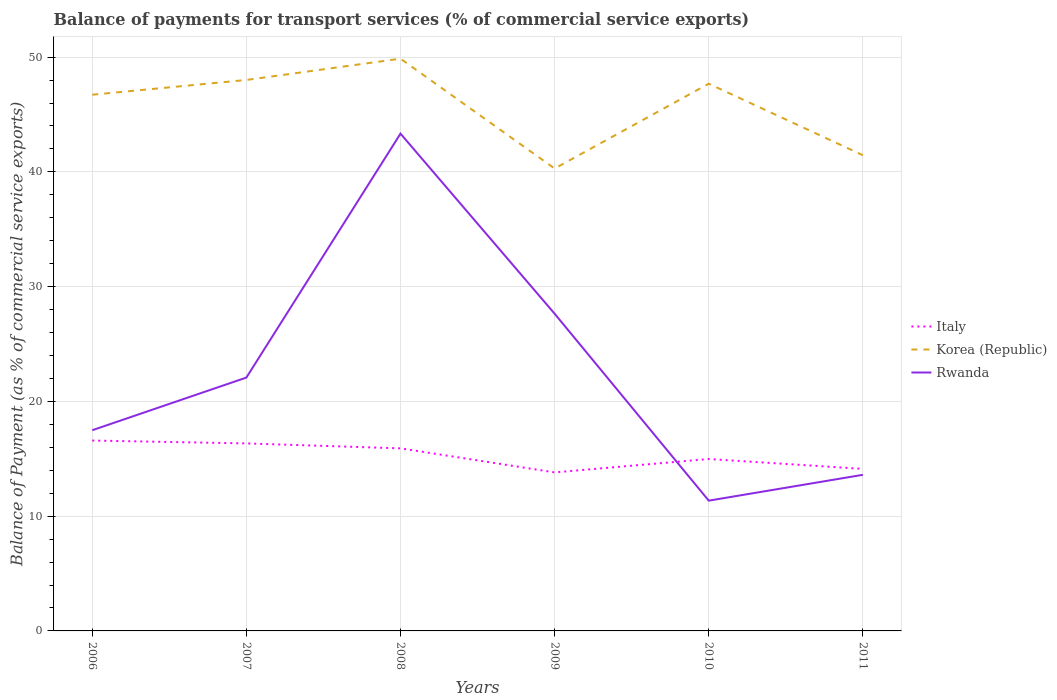Is the number of lines equal to the number of legend labels?
Your answer should be very brief. Yes. Across all years, what is the maximum balance of payments for transport services in Rwanda?
Make the answer very short. 11.35. What is the total balance of payments for transport services in Korea (Republic) in the graph?
Keep it short and to the point. -7.39. What is the difference between the highest and the second highest balance of payments for transport services in Italy?
Your response must be concise. 2.77. Is the balance of payments for transport services in Italy strictly greater than the balance of payments for transport services in Korea (Republic) over the years?
Provide a short and direct response. Yes. What is the difference between two consecutive major ticks on the Y-axis?
Ensure brevity in your answer.  10. Are the values on the major ticks of Y-axis written in scientific E-notation?
Ensure brevity in your answer.  No. Does the graph contain any zero values?
Offer a terse response. No. Does the graph contain grids?
Keep it short and to the point. Yes. Where does the legend appear in the graph?
Keep it short and to the point. Center right. What is the title of the graph?
Your answer should be compact. Balance of payments for transport services (% of commercial service exports). What is the label or title of the X-axis?
Ensure brevity in your answer.  Years. What is the label or title of the Y-axis?
Offer a terse response. Balance of Payment (as % of commercial service exports). What is the Balance of Payment (as % of commercial service exports) in Italy in 2006?
Keep it short and to the point. 16.59. What is the Balance of Payment (as % of commercial service exports) in Korea (Republic) in 2006?
Ensure brevity in your answer.  46.72. What is the Balance of Payment (as % of commercial service exports) in Rwanda in 2006?
Offer a very short reply. 17.49. What is the Balance of Payment (as % of commercial service exports) of Italy in 2007?
Your response must be concise. 16.34. What is the Balance of Payment (as % of commercial service exports) in Korea (Republic) in 2007?
Offer a very short reply. 48.01. What is the Balance of Payment (as % of commercial service exports) of Rwanda in 2007?
Your answer should be very brief. 22.08. What is the Balance of Payment (as % of commercial service exports) of Italy in 2008?
Offer a very short reply. 15.91. What is the Balance of Payment (as % of commercial service exports) of Korea (Republic) in 2008?
Keep it short and to the point. 49.86. What is the Balance of Payment (as % of commercial service exports) in Rwanda in 2008?
Offer a very short reply. 43.33. What is the Balance of Payment (as % of commercial service exports) in Italy in 2009?
Provide a succinct answer. 13.81. What is the Balance of Payment (as % of commercial service exports) in Korea (Republic) in 2009?
Ensure brevity in your answer.  40.29. What is the Balance of Payment (as % of commercial service exports) in Rwanda in 2009?
Your answer should be very brief. 27.64. What is the Balance of Payment (as % of commercial service exports) in Italy in 2010?
Ensure brevity in your answer.  14.98. What is the Balance of Payment (as % of commercial service exports) of Korea (Republic) in 2010?
Keep it short and to the point. 47.68. What is the Balance of Payment (as % of commercial service exports) in Rwanda in 2010?
Make the answer very short. 11.35. What is the Balance of Payment (as % of commercial service exports) in Italy in 2011?
Give a very brief answer. 14.12. What is the Balance of Payment (as % of commercial service exports) in Korea (Republic) in 2011?
Give a very brief answer. 41.45. What is the Balance of Payment (as % of commercial service exports) in Rwanda in 2011?
Your response must be concise. 13.6. Across all years, what is the maximum Balance of Payment (as % of commercial service exports) of Italy?
Give a very brief answer. 16.59. Across all years, what is the maximum Balance of Payment (as % of commercial service exports) of Korea (Republic)?
Your answer should be very brief. 49.86. Across all years, what is the maximum Balance of Payment (as % of commercial service exports) of Rwanda?
Your answer should be compact. 43.33. Across all years, what is the minimum Balance of Payment (as % of commercial service exports) in Italy?
Your response must be concise. 13.81. Across all years, what is the minimum Balance of Payment (as % of commercial service exports) of Korea (Republic)?
Offer a very short reply. 40.29. Across all years, what is the minimum Balance of Payment (as % of commercial service exports) of Rwanda?
Keep it short and to the point. 11.35. What is the total Balance of Payment (as % of commercial service exports) of Italy in the graph?
Make the answer very short. 91.75. What is the total Balance of Payment (as % of commercial service exports) in Korea (Republic) in the graph?
Offer a terse response. 274.02. What is the total Balance of Payment (as % of commercial service exports) in Rwanda in the graph?
Offer a terse response. 135.5. What is the difference between the Balance of Payment (as % of commercial service exports) in Italy in 2006 and that in 2007?
Your answer should be very brief. 0.25. What is the difference between the Balance of Payment (as % of commercial service exports) in Korea (Republic) in 2006 and that in 2007?
Keep it short and to the point. -1.29. What is the difference between the Balance of Payment (as % of commercial service exports) of Rwanda in 2006 and that in 2007?
Give a very brief answer. -4.59. What is the difference between the Balance of Payment (as % of commercial service exports) in Italy in 2006 and that in 2008?
Provide a succinct answer. 0.68. What is the difference between the Balance of Payment (as % of commercial service exports) of Korea (Republic) in 2006 and that in 2008?
Give a very brief answer. -3.14. What is the difference between the Balance of Payment (as % of commercial service exports) in Rwanda in 2006 and that in 2008?
Your response must be concise. -25.84. What is the difference between the Balance of Payment (as % of commercial service exports) of Italy in 2006 and that in 2009?
Provide a succinct answer. 2.77. What is the difference between the Balance of Payment (as % of commercial service exports) of Korea (Republic) in 2006 and that in 2009?
Your response must be concise. 6.43. What is the difference between the Balance of Payment (as % of commercial service exports) in Rwanda in 2006 and that in 2009?
Give a very brief answer. -10.15. What is the difference between the Balance of Payment (as % of commercial service exports) in Italy in 2006 and that in 2010?
Your response must be concise. 1.61. What is the difference between the Balance of Payment (as % of commercial service exports) of Korea (Republic) in 2006 and that in 2010?
Keep it short and to the point. -0.96. What is the difference between the Balance of Payment (as % of commercial service exports) in Rwanda in 2006 and that in 2010?
Your response must be concise. 6.14. What is the difference between the Balance of Payment (as % of commercial service exports) in Italy in 2006 and that in 2011?
Provide a short and direct response. 2.47. What is the difference between the Balance of Payment (as % of commercial service exports) in Korea (Republic) in 2006 and that in 2011?
Provide a succinct answer. 5.27. What is the difference between the Balance of Payment (as % of commercial service exports) of Rwanda in 2006 and that in 2011?
Provide a succinct answer. 3.89. What is the difference between the Balance of Payment (as % of commercial service exports) of Italy in 2007 and that in 2008?
Ensure brevity in your answer.  0.43. What is the difference between the Balance of Payment (as % of commercial service exports) of Korea (Republic) in 2007 and that in 2008?
Your response must be concise. -1.86. What is the difference between the Balance of Payment (as % of commercial service exports) in Rwanda in 2007 and that in 2008?
Offer a very short reply. -21.26. What is the difference between the Balance of Payment (as % of commercial service exports) of Italy in 2007 and that in 2009?
Your response must be concise. 2.53. What is the difference between the Balance of Payment (as % of commercial service exports) in Korea (Republic) in 2007 and that in 2009?
Ensure brevity in your answer.  7.72. What is the difference between the Balance of Payment (as % of commercial service exports) of Rwanda in 2007 and that in 2009?
Provide a short and direct response. -5.57. What is the difference between the Balance of Payment (as % of commercial service exports) in Italy in 2007 and that in 2010?
Make the answer very short. 1.36. What is the difference between the Balance of Payment (as % of commercial service exports) in Korea (Republic) in 2007 and that in 2010?
Your response must be concise. 0.33. What is the difference between the Balance of Payment (as % of commercial service exports) in Rwanda in 2007 and that in 2010?
Provide a succinct answer. 10.72. What is the difference between the Balance of Payment (as % of commercial service exports) in Italy in 2007 and that in 2011?
Your answer should be very brief. 2.22. What is the difference between the Balance of Payment (as % of commercial service exports) in Korea (Republic) in 2007 and that in 2011?
Make the answer very short. 6.56. What is the difference between the Balance of Payment (as % of commercial service exports) of Rwanda in 2007 and that in 2011?
Give a very brief answer. 8.47. What is the difference between the Balance of Payment (as % of commercial service exports) of Italy in 2008 and that in 2009?
Ensure brevity in your answer.  2.09. What is the difference between the Balance of Payment (as % of commercial service exports) of Korea (Republic) in 2008 and that in 2009?
Provide a succinct answer. 9.57. What is the difference between the Balance of Payment (as % of commercial service exports) of Rwanda in 2008 and that in 2009?
Your answer should be very brief. 15.69. What is the difference between the Balance of Payment (as % of commercial service exports) in Italy in 2008 and that in 2010?
Give a very brief answer. 0.93. What is the difference between the Balance of Payment (as % of commercial service exports) of Korea (Republic) in 2008 and that in 2010?
Keep it short and to the point. 2.18. What is the difference between the Balance of Payment (as % of commercial service exports) in Rwanda in 2008 and that in 2010?
Ensure brevity in your answer.  31.98. What is the difference between the Balance of Payment (as % of commercial service exports) of Italy in 2008 and that in 2011?
Ensure brevity in your answer.  1.79. What is the difference between the Balance of Payment (as % of commercial service exports) of Korea (Republic) in 2008 and that in 2011?
Provide a succinct answer. 8.41. What is the difference between the Balance of Payment (as % of commercial service exports) of Rwanda in 2008 and that in 2011?
Offer a terse response. 29.73. What is the difference between the Balance of Payment (as % of commercial service exports) in Italy in 2009 and that in 2010?
Make the answer very short. -1.17. What is the difference between the Balance of Payment (as % of commercial service exports) of Korea (Republic) in 2009 and that in 2010?
Your response must be concise. -7.39. What is the difference between the Balance of Payment (as % of commercial service exports) of Rwanda in 2009 and that in 2010?
Offer a very short reply. 16.29. What is the difference between the Balance of Payment (as % of commercial service exports) of Italy in 2009 and that in 2011?
Give a very brief answer. -0.3. What is the difference between the Balance of Payment (as % of commercial service exports) in Korea (Republic) in 2009 and that in 2011?
Make the answer very short. -1.16. What is the difference between the Balance of Payment (as % of commercial service exports) of Rwanda in 2009 and that in 2011?
Offer a very short reply. 14.04. What is the difference between the Balance of Payment (as % of commercial service exports) in Italy in 2010 and that in 2011?
Your answer should be very brief. 0.86. What is the difference between the Balance of Payment (as % of commercial service exports) in Korea (Republic) in 2010 and that in 2011?
Keep it short and to the point. 6.23. What is the difference between the Balance of Payment (as % of commercial service exports) in Rwanda in 2010 and that in 2011?
Ensure brevity in your answer.  -2.25. What is the difference between the Balance of Payment (as % of commercial service exports) of Italy in 2006 and the Balance of Payment (as % of commercial service exports) of Korea (Republic) in 2007?
Ensure brevity in your answer.  -31.42. What is the difference between the Balance of Payment (as % of commercial service exports) of Italy in 2006 and the Balance of Payment (as % of commercial service exports) of Rwanda in 2007?
Your answer should be very brief. -5.49. What is the difference between the Balance of Payment (as % of commercial service exports) in Korea (Republic) in 2006 and the Balance of Payment (as % of commercial service exports) in Rwanda in 2007?
Offer a very short reply. 24.65. What is the difference between the Balance of Payment (as % of commercial service exports) of Italy in 2006 and the Balance of Payment (as % of commercial service exports) of Korea (Republic) in 2008?
Offer a terse response. -33.28. What is the difference between the Balance of Payment (as % of commercial service exports) of Italy in 2006 and the Balance of Payment (as % of commercial service exports) of Rwanda in 2008?
Your answer should be very brief. -26.74. What is the difference between the Balance of Payment (as % of commercial service exports) of Korea (Republic) in 2006 and the Balance of Payment (as % of commercial service exports) of Rwanda in 2008?
Give a very brief answer. 3.39. What is the difference between the Balance of Payment (as % of commercial service exports) in Italy in 2006 and the Balance of Payment (as % of commercial service exports) in Korea (Republic) in 2009?
Give a very brief answer. -23.7. What is the difference between the Balance of Payment (as % of commercial service exports) in Italy in 2006 and the Balance of Payment (as % of commercial service exports) in Rwanda in 2009?
Give a very brief answer. -11.05. What is the difference between the Balance of Payment (as % of commercial service exports) in Korea (Republic) in 2006 and the Balance of Payment (as % of commercial service exports) in Rwanda in 2009?
Offer a terse response. 19.08. What is the difference between the Balance of Payment (as % of commercial service exports) in Italy in 2006 and the Balance of Payment (as % of commercial service exports) in Korea (Republic) in 2010?
Make the answer very short. -31.09. What is the difference between the Balance of Payment (as % of commercial service exports) of Italy in 2006 and the Balance of Payment (as % of commercial service exports) of Rwanda in 2010?
Provide a short and direct response. 5.24. What is the difference between the Balance of Payment (as % of commercial service exports) of Korea (Republic) in 2006 and the Balance of Payment (as % of commercial service exports) of Rwanda in 2010?
Your answer should be compact. 35.37. What is the difference between the Balance of Payment (as % of commercial service exports) of Italy in 2006 and the Balance of Payment (as % of commercial service exports) of Korea (Republic) in 2011?
Ensure brevity in your answer.  -24.86. What is the difference between the Balance of Payment (as % of commercial service exports) in Italy in 2006 and the Balance of Payment (as % of commercial service exports) in Rwanda in 2011?
Offer a terse response. 2.99. What is the difference between the Balance of Payment (as % of commercial service exports) in Korea (Republic) in 2006 and the Balance of Payment (as % of commercial service exports) in Rwanda in 2011?
Provide a succinct answer. 33.12. What is the difference between the Balance of Payment (as % of commercial service exports) of Italy in 2007 and the Balance of Payment (as % of commercial service exports) of Korea (Republic) in 2008?
Provide a succinct answer. -33.53. What is the difference between the Balance of Payment (as % of commercial service exports) of Italy in 2007 and the Balance of Payment (as % of commercial service exports) of Rwanda in 2008?
Provide a succinct answer. -26.99. What is the difference between the Balance of Payment (as % of commercial service exports) of Korea (Republic) in 2007 and the Balance of Payment (as % of commercial service exports) of Rwanda in 2008?
Provide a short and direct response. 4.68. What is the difference between the Balance of Payment (as % of commercial service exports) in Italy in 2007 and the Balance of Payment (as % of commercial service exports) in Korea (Republic) in 2009?
Ensure brevity in your answer.  -23.95. What is the difference between the Balance of Payment (as % of commercial service exports) in Italy in 2007 and the Balance of Payment (as % of commercial service exports) in Rwanda in 2009?
Your answer should be very brief. -11.3. What is the difference between the Balance of Payment (as % of commercial service exports) of Korea (Republic) in 2007 and the Balance of Payment (as % of commercial service exports) of Rwanda in 2009?
Your answer should be very brief. 20.37. What is the difference between the Balance of Payment (as % of commercial service exports) in Italy in 2007 and the Balance of Payment (as % of commercial service exports) in Korea (Republic) in 2010?
Make the answer very short. -31.34. What is the difference between the Balance of Payment (as % of commercial service exports) of Italy in 2007 and the Balance of Payment (as % of commercial service exports) of Rwanda in 2010?
Offer a very short reply. 4.99. What is the difference between the Balance of Payment (as % of commercial service exports) in Korea (Republic) in 2007 and the Balance of Payment (as % of commercial service exports) in Rwanda in 2010?
Your answer should be compact. 36.66. What is the difference between the Balance of Payment (as % of commercial service exports) of Italy in 2007 and the Balance of Payment (as % of commercial service exports) of Korea (Republic) in 2011?
Provide a short and direct response. -25.11. What is the difference between the Balance of Payment (as % of commercial service exports) in Italy in 2007 and the Balance of Payment (as % of commercial service exports) in Rwanda in 2011?
Offer a very short reply. 2.74. What is the difference between the Balance of Payment (as % of commercial service exports) of Korea (Republic) in 2007 and the Balance of Payment (as % of commercial service exports) of Rwanda in 2011?
Your response must be concise. 34.41. What is the difference between the Balance of Payment (as % of commercial service exports) in Italy in 2008 and the Balance of Payment (as % of commercial service exports) in Korea (Republic) in 2009?
Offer a terse response. -24.38. What is the difference between the Balance of Payment (as % of commercial service exports) in Italy in 2008 and the Balance of Payment (as % of commercial service exports) in Rwanda in 2009?
Give a very brief answer. -11.73. What is the difference between the Balance of Payment (as % of commercial service exports) of Korea (Republic) in 2008 and the Balance of Payment (as % of commercial service exports) of Rwanda in 2009?
Give a very brief answer. 22.22. What is the difference between the Balance of Payment (as % of commercial service exports) in Italy in 2008 and the Balance of Payment (as % of commercial service exports) in Korea (Republic) in 2010?
Offer a terse response. -31.77. What is the difference between the Balance of Payment (as % of commercial service exports) of Italy in 2008 and the Balance of Payment (as % of commercial service exports) of Rwanda in 2010?
Provide a short and direct response. 4.56. What is the difference between the Balance of Payment (as % of commercial service exports) in Korea (Republic) in 2008 and the Balance of Payment (as % of commercial service exports) in Rwanda in 2010?
Make the answer very short. 38.51. What is the difference between the Balance of Payment (as % of commercial service exports) of Italy in 2008 and the Balance of Payment (as % of commercial service exports) of Korea (Republic) in 2011?
Provide a short and direct response. -25.54. What is the difference between the Balance of Payment (as % of commercial service exports) in Italy in 2008 and the Balance of Payment (as % of commercial service exports) in Rwanda in 2011?
Your response must be concise. 2.31. What is the difference between the Balance of Payment (as % of commercial service exports) in Korea (Republic) in 2008 and the Balance of Payment (as % of commercial service exports) in Rwanda in 2011?
Keep it short and to the point. 36.26. What is the difference between the Balance of Payment (as % of commercial service exports) in Italy in 2009 and the Balance of Payment (as % of commercial service exports) in Korea (Republic) in 2010?
Make the answer very short. -33.87. What is the difference between the Balance of Payment (as % of commercial service exports) of Italy in 2009 and the Balance of Payment (as % of commercial service exports) of Rwanda in 2010?
Ensure brevity in your answer.  2.46. What is the difference between the Balance of Payment (as % of commercial service exports) of Korea (Republic) in 2009 and the Balance of Payment (as % of commercial service exports) of Rwanda in 2010?
Offer a very short reply. 28.94. What is the difference between the Balance of Payment (as % of commercial service exports) in Italy in 2009 and the Balance of Payment (as % of commercial service exports) in Korea (Republic) in 2011?
Give a very brief answer. -27.64. What is the difference between the Balance of Payment (as % of commercial service exports) of Italy in 2009 and the Balance of Payment (as % of commercial service exports) of Rwanda in 2011?
Keep it short and to the point. 0.21. What is the difference between the Balance of Payment (as % of commercial service exports) of Korea (Republic) in 2009 and the Balance of Payment (as % of commercial service exports) of Rwanda in 2011?
Offer a very short reply. 26.69. What is the difference between the Balance of Payment (as % of commercial service exports) in Italy in 2010 and the Balance of Payment (as % of commercial service exports) in Korea (Republic) in 2011?
Provide a short and direct response. -26.47. What is the difference between the Balance of Payment (as % of commercial service exports) in Italy in 2010 and the Balance of Payment (as % of commercial service exports) in Rwanda in 2011?
Your response must be concise. 1.38. What is the difference between the Balance of Payment (as % of commercial service exports) of Korea (Republic) in 2010 and the Balance of Payment (as % of commercial service exports) of Rwanda in 2011?
Your response must be concise. 34.08. What is the average Balance of Payment (as % of commercial service exports) in Italy per year?
Your response must be concise. 15.29. What is the average Balance of Payment (as % of commercial service exports) in Korea (Republic) per year?
Give a very brief answer. 45.67. What is the average Balance of Payment (as % of commercial service exports) in Rwanda per year?
Offer a terse response. 22.58. In the year 2006, what is the difference between the Balance of Payment (as % of commercial service exports) in Italy and Balance of Payment (as % of commercial service exports) in Korea (Republic)?
Give a very brief answer. -30.14. In the year 2006, what is the difference between the Balance of Payment (as % of commercial service exports) of Italy and Balance of Payment (as % of commercial service exports) of Rwanda?
Keep it short and to the point. -0.9. In the year 2006, what is the difference between the Balance of Payment (as % of commercial service exports) of Korea (Republic) and Balance of Payment (as % of commercial service exports) of Rwanda?
Offer a very short reply. 29.24. In the year 2007, what is the difference between the Balance of Payment (as % of commercial service exports) in Italy and Balance of Payment (as % of commercial service exports) in Korea (Republic)?
Your answer should be compact. -31.67. In the year 2007, what is the difference between the Balance of Payment (as % of commercial service exports) of Italy and Balance of Payment (as % of commercial service exports) of Rwanda?
Ensure brevity in your answer.  -5.74. In the year 2007, what is the difference between the Balance of Payment (as % of commercial service exports) in Korea (Republic) and Balance of Payment (as % of commercial service exports) in Rwanda?
Offer a very short reply. 25.93. In the year 2008, what is the difference between the Balance of Payment (as % of commercial service exports) in Italy and Balance of Payment (as % of commercial service exports) in Korea (Republic)?
Offer a terse response. -33.96. In the year 2008, what is the difference between the Balance of Payment (as % of commercial service exports) of Italy and Balance of Payment (as % of commercial service exports) of Rwanda?
Offer a very short reply. -27.42. In the year 2008, what is the difference between the Balance of Payment (as % of commercial service exports) in Korea (Republic) and Balance of Payment (as % of commercial service exports) in Rwanda?
Provide a succinct answer. 6.53. In the year 2009, what is the difference between the Balance of Payment (as % of commercial service exports) of Italy and Balance of Payment (as % of commercial service exports) of Korea (Republic)?
Make the answer very short. -26.48. In the year 2009, what is the difference between the Balance of Payment (as % of commercial service exports) in Italy and Balance of Payment (as % of commercial service exports) in Rwanda?
Keep it short and to the point. -13.83. In the year 2009, what is the difference between the Balance of Payment (as % of commercial service exports) of Korea (Republic) and Balance of Payment (as % of commercial service exports) of Rwanda?
Your answer should be very brief. 12.65. In the year 2010, what is the difference between the Balance of Payment (as % of commercial service exports) of Italy and Balance of Payment (as % of commercial service exports) of Korea (Republic)?
Your answer should be compact. -32.7. In the year 2010, what is the difference between the Balance of Payment (as % of commercial service exports) in Italy and Balance of Payment (as % of commercial service exports) in Rwanda?
Provide a short and direct response. 3.63. In the year 2010, what is the difference between the Balance of Payment (as % of commercial service exports) of Korea (Republic) and Balance of Payment (as % of commercial service exports) of Rwanda?
Provide a short and direct response. 36.33. In the year 2011, what is the difference between the Balance of Payment (as % of commercial service exports) in Italy and Balance of Payment (as % of commercial service exports) in Korea (Republic)?
Make the answer very short. -27.33. In the year 2011, what is the difference between the Balance of Payment (as % of commercial service exports) in Italy and Balance of Payment (as % of commercial service exports) in Rwanda?
Keep it short and to the point. 0.52. In the year 2011, what is the difference between the Balance of Payment (as % of commercial service exports) in Korea (Republic) and Balance of Payment (as % of commercial service exports) in Rwanda?
Make the answer very short. 27.85. What is the ratio of the Balance of Payment (as % of commercial service exports) of Italy in 2006 to that in 2007?
Offer a very short reply. 1.02. What is the ratio of the Balance of Payment (as % of commercial service exports) of Korea (Republic) in 2006 to that in 2007?
Your answer should be compact. 0.97. What is the ratio of the Balance of Payment (as % of commercial service exports) in Rwanda in 2006 to that in 2007?
Give a very brief answer. 0.79. What is the ratio of the Balance of Payment (as % of commercial service exports) in Italy in 2006 to that in 2008?
Give a very brief answer. 1.04. What is the ratio of the Balance of Payment (as % of commercial service exports) in Korea (Republic) in 2006 to that in 2008?
Your response must be concise. 0.94. What is the ratio of the Balance of Payment (as % of commercial service exports) in Rwanda in 2006 to that in 2008?
Give a very brief answer. 0.4. What is the ratio of the Balance of Payment (as % of commercial service exports) in Italy in 2006 to that in 2009?
Keep it short and to the point. 1.2. What is the ratio of the Balance of Payment (as % of commercial service exports) of Korea (Republic) in 2006 to that in 2009?
Offer a terse response. 1.16. What is the ratio of the Balance of Payment (as % of commercial service exports) of Rwanda in 2006 to that in 2009?
Your response must be concise. 0.63. What is the ratio of the Balance of Payment (as % of commercial service exports) in Italy in 2006 to that in 2010?
Provide a short and direct response. 1.11. What is the ratio of the Balance of Payment (as % of commercial service exports) of Korea (Republic) in 2006 to that in 2010?
Ensure brevity in your answer.  0.98. What is the ratio of the Balance of Payment (as % of commercial service exports) of Rwanda in 2006 to that in 2010?
Ensure brevity in your answer.  1.54. What is the ratio of the Balance of Payment (as % of commercial service exports) of Italy in 2006 to that in 2011?
Your answer should be compact. 1.17. What is the ratio of the Balance of Payment (as % of commercial service exports) of Korea (Republic) in 2006 to that in 2011?
Keep it short and to the point. 1.13. What is the ratio of the Balance of Payment (as % of commercial service exports) of Italy in 2007 to that in 2008?
Provide a short and direct response. 1.03. What is the ratio of the Balance of Payment (as % of commercial service exports) of Korea (Republic) in 2007 to that in 2008?
Your answer should be very brief. 0.96. What is the ratio of the Balance of Payment (as % of commercial service exports) in Rwanda in 2007 to that in 2008?
Offer a very short reply. 0.51. What is the ratio of the Balance of Payment (as % of commercial service exports) in Italy in 2007 to that in 2009?
Ensure brevity in your answer.  1.18. What is the ratio of the Balance of Payment (as % of commercial service exports) of Korea (Republic) in 2007 to that in 2009?
Provide a succinct answer. 1.19. What is the ratio of the Balance of Payment (as % of commercial service exports) of Rwanda in 2007 to that in 2009?
Your answer should be very brief. 0.8. What is the ratio of the Balance of Payment (as % of commercial service exports) of Italy in 2007 to that in 2010?
Keep it short and to the point. 1.09. What is the ratio of the Balance of Payment (as % of commercial service exports) of Rwanda in 2007 to that in 2010?
Give a very brief answer. 1.94. What is the ratio of the Balance of Payment (as % of commercial service exports) in Italy in 2007 to that in 2011?
Provide a short and direct response. 1.16. What is the ratio of the Balance of Payment (as % of commercial service exports) of Korea (Republic) in 2007 to that in 2011?
Your answer should be very brief. 1.16. What is the ratio of the Balance of Payment (as % of commercial service exports) in Rwanda in 2007 to that in 2011?
Offer a terse response. 1.62. What is the ratio of the Balance of Payment (as % of commercial service exports) in Italy in 2008 to that in 2009?
Make the answer very short. 1.15. What is the ratio of the Balance of Payment (as % of commercial service exports) in Korea (Republic) in 2008 to that in 2009?
Ensure brevity in your answer.  1.24. What is the ratio of the Balance of Payment (as % of commercial service exports) in Rwanda in 2008 to that in 2009?
Ensure brevity in your answer.  1.57. What is the ratio of the Balance of Payment (as % of commercial service exports) of Italy in 2008 to that in 2010?
Your answer should be compact. 1.06. What is the ratio of the Balance of Payment (as % of commercial service exports) of Korea (Republic) in 2008 to that in 2010?
Make the answer very short. 1.05. What is the ratio of the Balance of Payment (as % of commercial service exports) in Rwanda in 2008 to that in 2010?
Give a very brief answer. 3.82. What is the ratio of the Balance of Payment (as % of commercial service exports) of Italy in 2008 to that in 2011?
Offer a very short reply. 1.13. What is the ratio of the Balance of Payment (as % of commercial service exports) in Korea (Republic) in 2008 to that in 2011?
Your response must be concise. 1.2. What is the ratio of the Balance of Payment (as % of commercial service exports) in Rwanda in 2008 to that in 2011?
Offer a terse response. 3.19. What is the ratio of the Balance of Payment (as % of commercial service exports) in Italy in 2009 to that in 2010?
Your answer should be compact. 0.92. What is the ratio of the Balance of Payment (as % of commercial service exports) in Korea (Republic) in 2009 to that in 2010?
Give a very brief answer. 0.84. What is the ratio of the Balance of Payment (as % of commercial service exports) of Rwanda in 2009 to that in 2010?
Your answer should be compact. 2.44. What is the ratio of the Balance of Payment (as % of commercial service exports) of Italy in 2009 to that in 2011?
Your answer should be compact. 0.98. What is the ratio of the Balance of Payment (as % of commercial service exports) in Rwanda in 2009 to that in 2011?
Your response must be concise. 2.03. What is the ratio of the Balance of Payment (as % of commercial service exports) of Italy in 2010 to that in 2011?
Provide a succinct answer. 1.06. What is the ratio of the Balance of Payment (as % of commercial service exports) in Korea (Republic) in 2010 to that in 2011?
Ensure brevity in your answer.  1.15. What is the ratio of the Balance of Payment (as % of commercial service exports) in Rwanda in 2010 to that in 2011?
Offer a very short reply. 0.83. What is the difference between the highest and the second highest Balance of Payment (as % of commercial service exports) in Italy?
Keep it short and to the point. 0.25. What is the difference between the highest and the second highest Balance of Payment (as % of commercial service exports) of Korea (Republic)?
Offer a terse response. 1.86. What is the difference between the highest and the second highest Balance of Payment (as % of commercial service exports) of Rwanda?
Provide a succinct answer. 15.69. What is the difference between the highest and the lowest Balance of Payment (as % of commercial service exports) in Italy?
Ensure brevity in your answer.  2.77. What is the difference between the highest and the lowest Balance of Payment (as % of commercial service exports) of Korea (Republic)?
Keep it short and to the point. 9.57. What is the difference between the highest and the lowest Balance of Payment (as % of commercial service exports) in Rwanda?
Offer a very short reply. 31.98. 